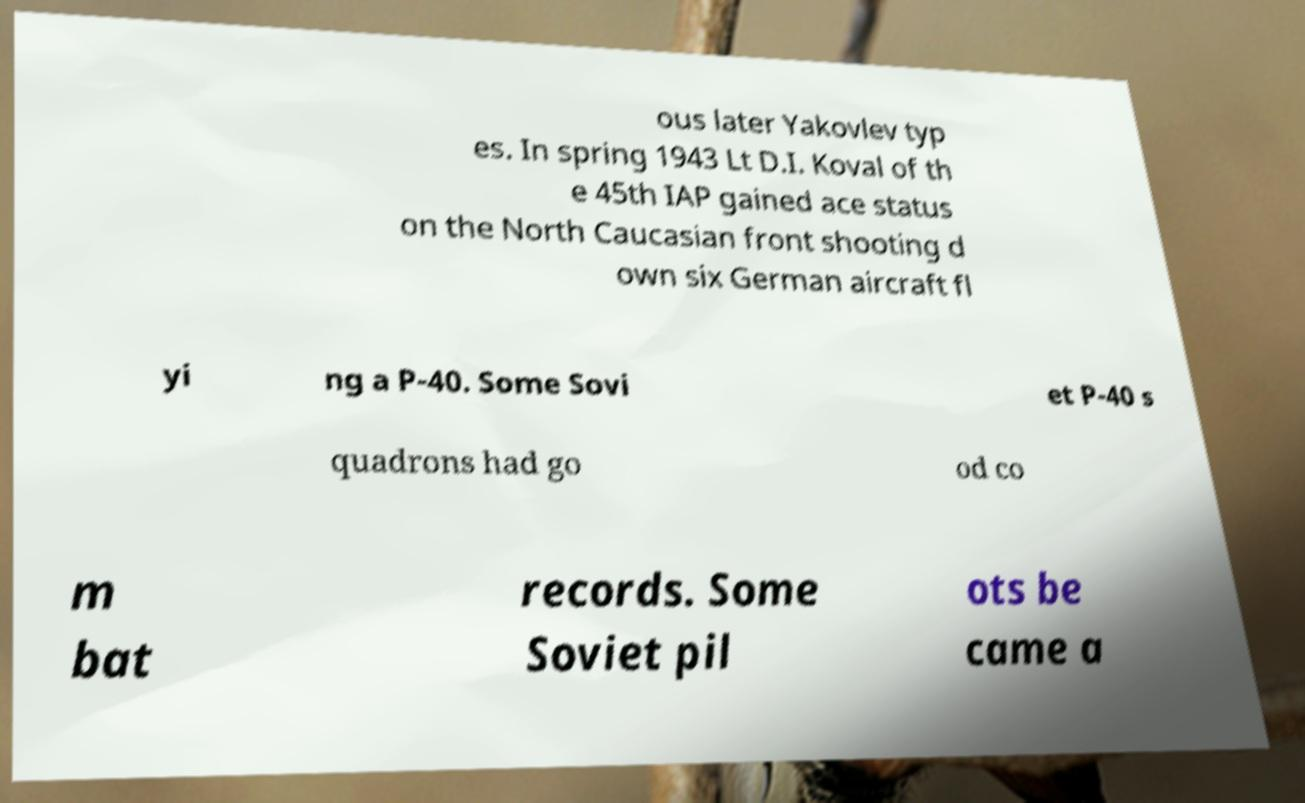Please read and relay the text visible in this image. What does it say? ous later Yakovlev typ es. In spring 1943 Lt D.I. Koval of th e 45th IAP gained ace status on the North Caucasian front shooting d own six German aircraft fl yi ng a P-40. Some Sovi et P-40 s quadrons had go od co m bat records. Some Soviet pil ots be came a 